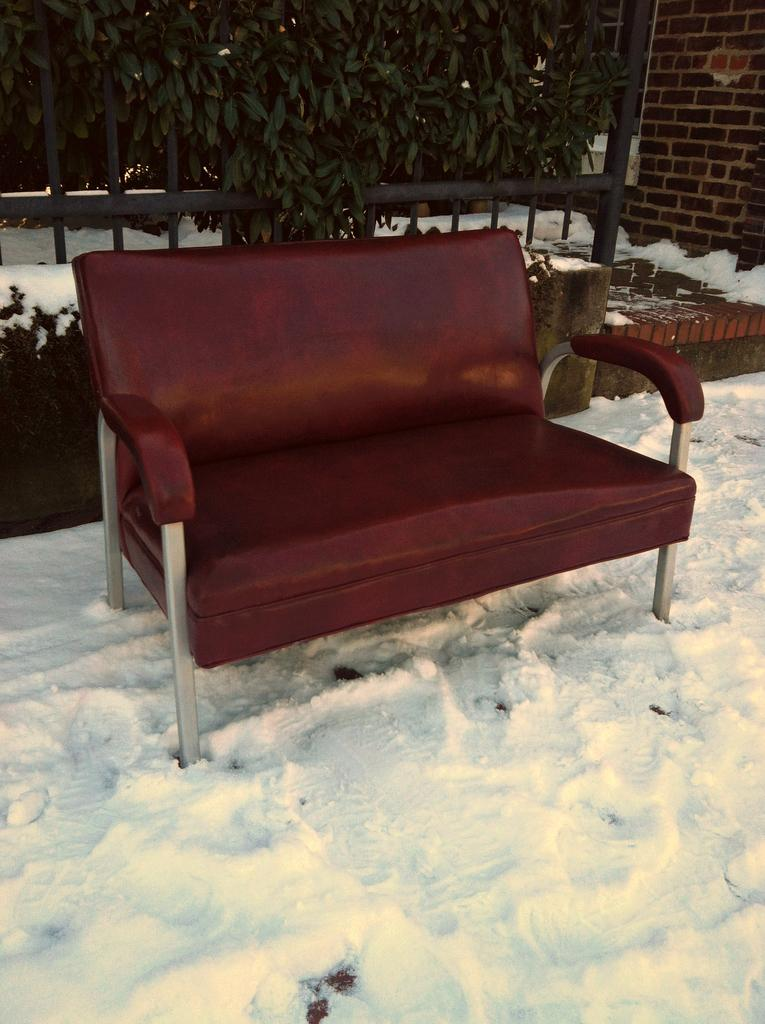What type of furniture is in the image? There is a couch in the image. Where is the couch located? The couch is on the snow. What can be seen behind the couch? There is a tree and an iron grille behind the couch. What is visible in the top right corner of the image? There is a wall visible in the top right corner of the image. What type of brush is being used to clean the hose in the image? There is no brush or hose present in the image. 